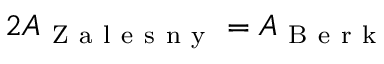Convert formula to latex. <formula><loc_0><loc_0><loc_500><loc_500>2 A _ { Z a l e s n y } = A _ { B e r k }</formula> 